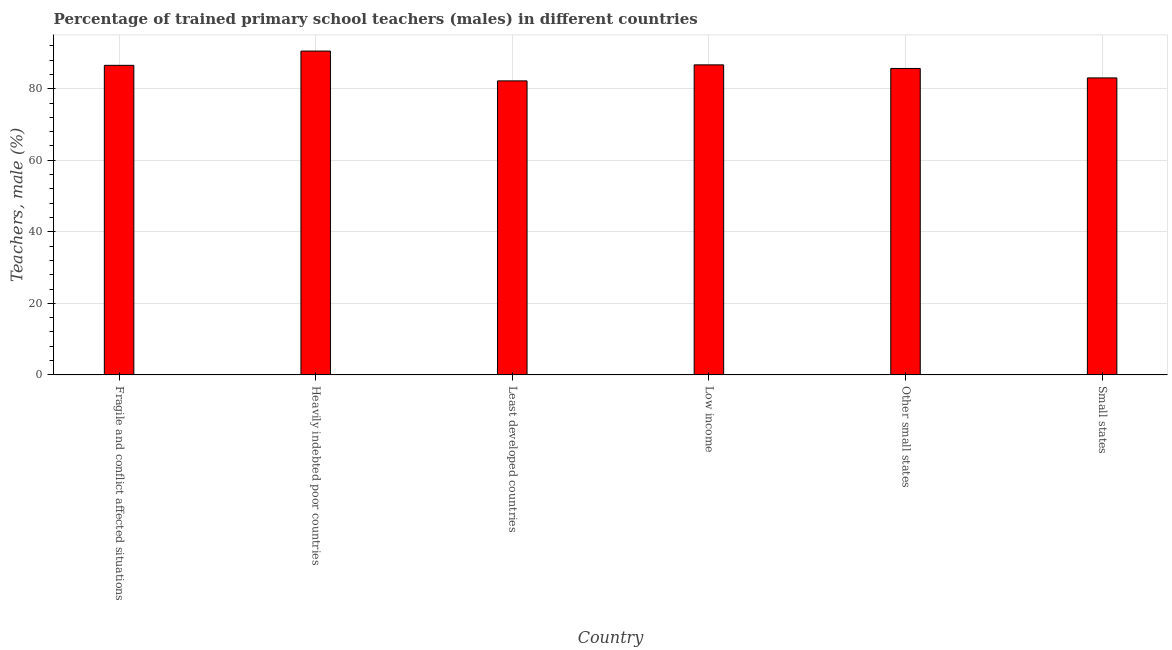Does the graph contain grids?
Make the answer very short. Yes. What is the title of the graph?
Your response must be concise. Percentage of trained primary school teachers (males) in different countries. What is the label or title of the Y-axis?
Ensure brevity in your answer.  Teachers, male (%). What is the percentage of trained male teachers in Least developed countries?
Ensure brevity in your answer.  82.18. Across all countries, what is the maximum percentage of trained male teachers?
Your answer should be compact. 90.52. Across all countries, what is the minimum percentage of trained male teachers?
Make the answer very short. 82.18. In which country was the percentage of trained male teachers maximum?
Offer a terse response. Heavily indebted poor countries. In which country was the percentage of trained male teachers minimum?
Provide a short and direct response. Least developed countries. What is the sum of the percentage of trained male teachers?
Provide a short and direct response. 514.56. What is the difference between the percentage of trained male teachers in Fragile and conflict affected situations and Least developed countries?
Ensure brevity in your answer.  4.35. What is the average percentage of trained male teachers per country?
Make the answer very short. 85.76. What is the median percentage of trained male teachers?
Ensure brevity in your answer.  86.09. What is the ratio of the percentage of trained male teachers in Fragile and conflict affected situations to that in Heavily indebted poor countries?
Provide a succinct answer. 0.96. Is the percentage of trained male teachers in Fragile and conflict affected situations less than that in Least developed countries?
Provide a succinct answer. No. Is the difference between the percentage of trained male teachers in Heavily indebted poor countries and Small states greater than the difference between any two countries?
Offer a terse response. No. What is the difference between the highest and the second highest percentage of trained male teachers?
Provide a succinct answer. 3.86. Is the sum of the percentage of trained male teachers in Fragile and conflict affected situations and Other small states greater than the maximum percentage of trained male teachers across all countries?
Keep it short and to the point. Yes. What is the difference between the highest and the lowest percentage of trained male teachers?
Your answer should be compact. 8.34. How many bars are there?
Provide a succinct answer. 6. How many countries are there in the graph?
Ensure brevity in your answer.  6. What is the difference between two consecutive major ticks on the Y-axis?
Provide a succinct answer. 20. Are the values on the major ticks of Y-axis written in scientific E-notation?
Provide a succinct answer. No. What is the Teachers, male (%) of Fragile and conflict affected situations?
Make the answer very short. 86.53. What is the Teachers, male (%) of Heavily indebted poor countries?
Make the answer very short. 90.52. What is the Teachers, male (%) in Least developed countries?
Give a very brief answer. 82.18. What is the Teachers, male (%) of Low income?
Provide a succinct answer. 86.66. What is the Teachers, male (%) in Other small states?
Your answer should be compact. 85.65. What is the Teachers, male (%) of Small states?
Your answer should be very brief. 83.01. What is the difference between the Teachers, male (%) in Fragile and conflict affected situations and Heavily indebted poor countries?
Offer a terse response. -3.99. What is the difference between the Teachers, male (%) in Fragile and conflict affected situations and Least developed countries?
Provide a succinct answer. 4.35. What is the difference between the Teachers, male (%) in Fragile and conflict affected situations and Low income?
Offer a terse response. -0.13. What is the difference between the Teachers, male (%) in Fragile and conflict affected situations and Other small states?
Your answer should be very brief. 0.88. What is the difference between the Teachers, male (%) in Fragile and conflict affected situations and Small states?
Provide a succinct answer. 3.52. What is the difference between the Teachers, male (%) in Heavily indebted poor countries and Least developed countries?
Your response must be concise. 8.34. What is the difference between the Teachers, male (%) in Heavily indebted poor countries and Low income?
Keep it short and to the point. 3.86. What is the difference between the Teachers, male (%) in Heavily indebted poor countries and Other small states?
Provide a short and direct response. 4.86. What is the difference between the Teachers, male (%) in Heavily indebted poor countries and Small states?
Offer a very short reply. 7.5. What is the difference between the Teachers, male (%) in Least developed countries and Low income?
Offer a very short reply. -4.48. What is the difference between the Teachers, male (%) in Least developed countries and Other small states?
Your answer should be compact. -3.47. What is the difference between the Teachers, male (%) in Least developed countries and Small states?
Your response must be concise. -0.83. What is the difference between the Teachers, male (%) in Low income and Other small states?
Make the answer very short. 1. What is the difference between the Teachers, male (%) in Low income and Small states?
Make the answer very short. 3.64. What is the difference between the Teachers, male (%) in Other small states and Small states?
Make the answer very short. 2.64. What is the ratio of the Teachers, male (%) in Fragile and conflict affected situations to that in Heavily indebted poor countries?
Your response must be concise. 0.96. What is the ratio of the Teachers, male (%) in Fragile and conflict affected situations to that in Least developed countries?
Your answer should be compact. 1.05. What is the ratio of the Teachers, male (%) in Fragile and conflict affected situations to that in Other small states?
Your answer should be very brief. 1.01. What is the ratio of the Teachers, male (%) in Fragile and conflict affected situations to that in Small states?
Offer a terse response. 1.04. What is the ratio of the Teachers, male (%) in Heavily indebted poor countries to that in Least developed countries?
Your answer should be very brief. 1.1. What is the ratio of the Teachers, male (%) in Heavily indebted poor countries to that in Low income?
Give a very brief answer. 1.04. What is the ratio of the Teachers, male (%) in Heavily indebted poor countries to that in Other small states?
Ensure brevity in your answer.  1.06. What is the ratio of the Teachers, male (%) in Heavily indebted poor countries to that in Small states?
Make the answer very short. 1.09. What is the ratio of the Teachers, male (%) in Least developed countries to that in Low income?
Your answer should be very brief. 0.95. What is the ratio of the Teachers, male (%) in Low income to that in Other small states?
Keep it short and to the point. 1.01. What is the ratio of the Teachers, male (%) in Low income to that in Small states?
Ensure brevity in your answer.  1.04. What is the ratio of the Teachers, male (%) in Other small states to that in Small states?
Give a very brief answer. 1.03. 